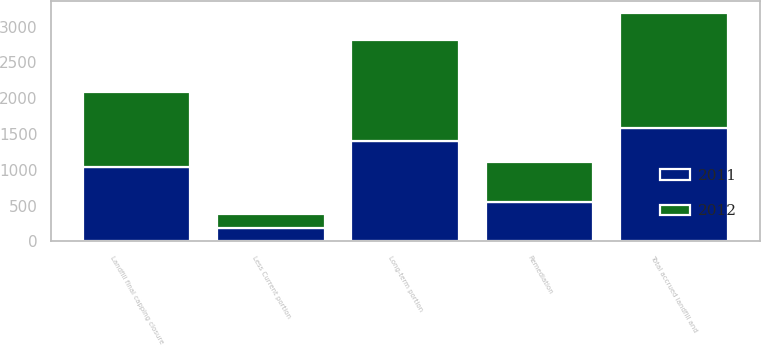Convert chart. <chart><loc_0><loc_0><loc_500><loc_500><stacked_bar_chart><ecel><fcel>Landfill final capping closure<fcel>Remediation<fcel>Total accrued landfill and<fcel>Less Current portion<fcel>Long-term portion<nl><fcel>2012<fcel>1052.4<fcel>563.7<fcel>1616.1<fcel>195.5<fcel>1420.6<nl><fcel>2011<fcel>1037<fcel>543.7<fcel>1580.7<fcel>184.2<fcel>1396.5<nl></chart> 